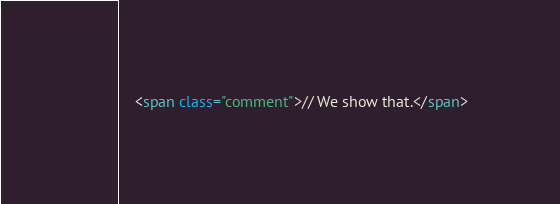<code> <loc_0><loc_0><loc_500><loc_500><_HTML_>    <span class="comment">// We show that.</span></code> 